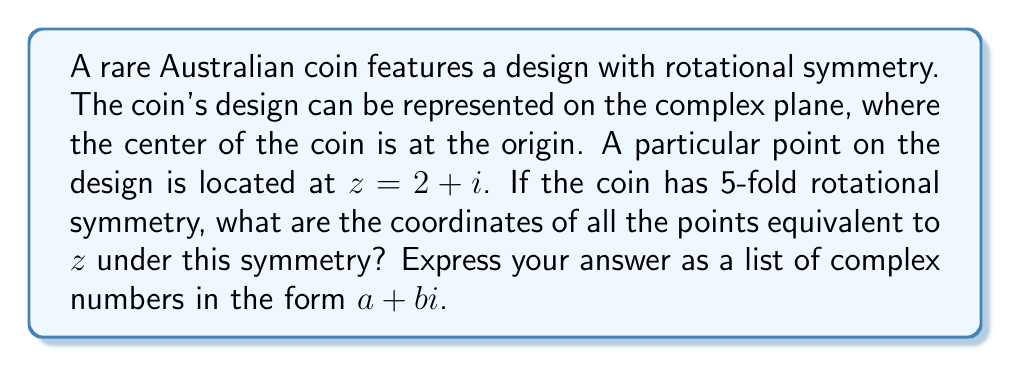Teach me how to tackle this problem. To solve this problem, we need to use complex rotations. The n-fold rotational symmetry of an object means that rotating the object by $\frac{360°}{n}$ (or $\frac{2\pi}{n}$ radians) about its center will produce an identical configuration.

For a 5-fold rotational symmetry, we need to rotate the point $z = 2 + i$ by multiples of $\frac{2\pi}{5}$ radians.

The formula for rotating a complex number $z$ by an angle $\theta$ is:

$$z' = ze^{i\theta}$$

where $e^{i\theta} = \cos\theta + i\sin\theta$ (Euler's formula).

We need to find $z'$ for $\theta = \frac{2\pi}{5}, \frac{4\pi}{5}, \frac{6\pi}{5}, \frac{8\pi}{5}$ (note that $\frac{10\pi}{5} = 2\pi$ brings us back to the starting point).

1) Original point: $z_0 = 2 + i$

2) First rotation ($\frac{2\pi}{5}$):
   $z_1 = (2+i)(\cos\frac{2\pi}{5} + i\sin\frac{2\pi}{5})$
   $= (2+i)(0.309 + 0.951i)$
   $\approx 0.618 + 2.245i$

3) Second rotation ($\frac{4\pi}{5}$):
   $z_2 = (2+i)(\cos\frac{4\pi}{5} + i\sin\frac{4\pi}{5})$
   $= (2+i)(-0.809 + 0.588i)$
   $\approx -1.618 + 1.176i$

4) Third rotation ($\frac{6\pi}{5}$):
   $z_3 = (2+i)(\cos\frac{6\pi}{5} + i\sin\frac{6\pi}{5})$
   $= (2+i)(-0.809 - 0.588i)$
   $\approx -1.618 - 1.176i$

5) Fourth rotation ($\frac{8\pi}{5}$):
   $z_4 = (2+i)(\cos\frac{8\pi}{5} + i\sin\frac{8\pi}{5})$
   $= (2+i)(0.309 - 0.951i)$
   $\approx 0.618 - 2.245i$

These five points, including the original point, form the vertices of a regular pentagon on the complex plane, representing the 5-fold rotational symmetry of the coin design.
Answer: The coordinates of all points equivalent to $z = 2 + i$ under 5-fold rotational symmetry are:
$2 + i$, $0.618 + 2.245i$, $-1.618 + 1.176i$, $-1.618 - 1.176i$, and $0.618 - 2.245i$ (rounded to three decimal places). 